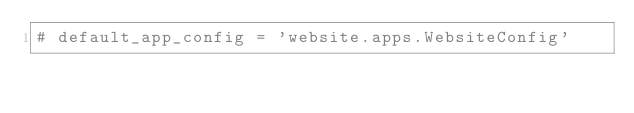Convert code to text. <code><loc_0><loc_0><loc_500><loc_500><_Python_># default_app_config = 'website.apps.WebsiteConfig'
</code> 